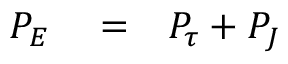<formula> <loc_0><loc_0><loc_500><loc_500>\begin{array} { r l r } { P _ { E } } & = } & { P _ { \tau } + P _ { J } } \end{array}</formula> 